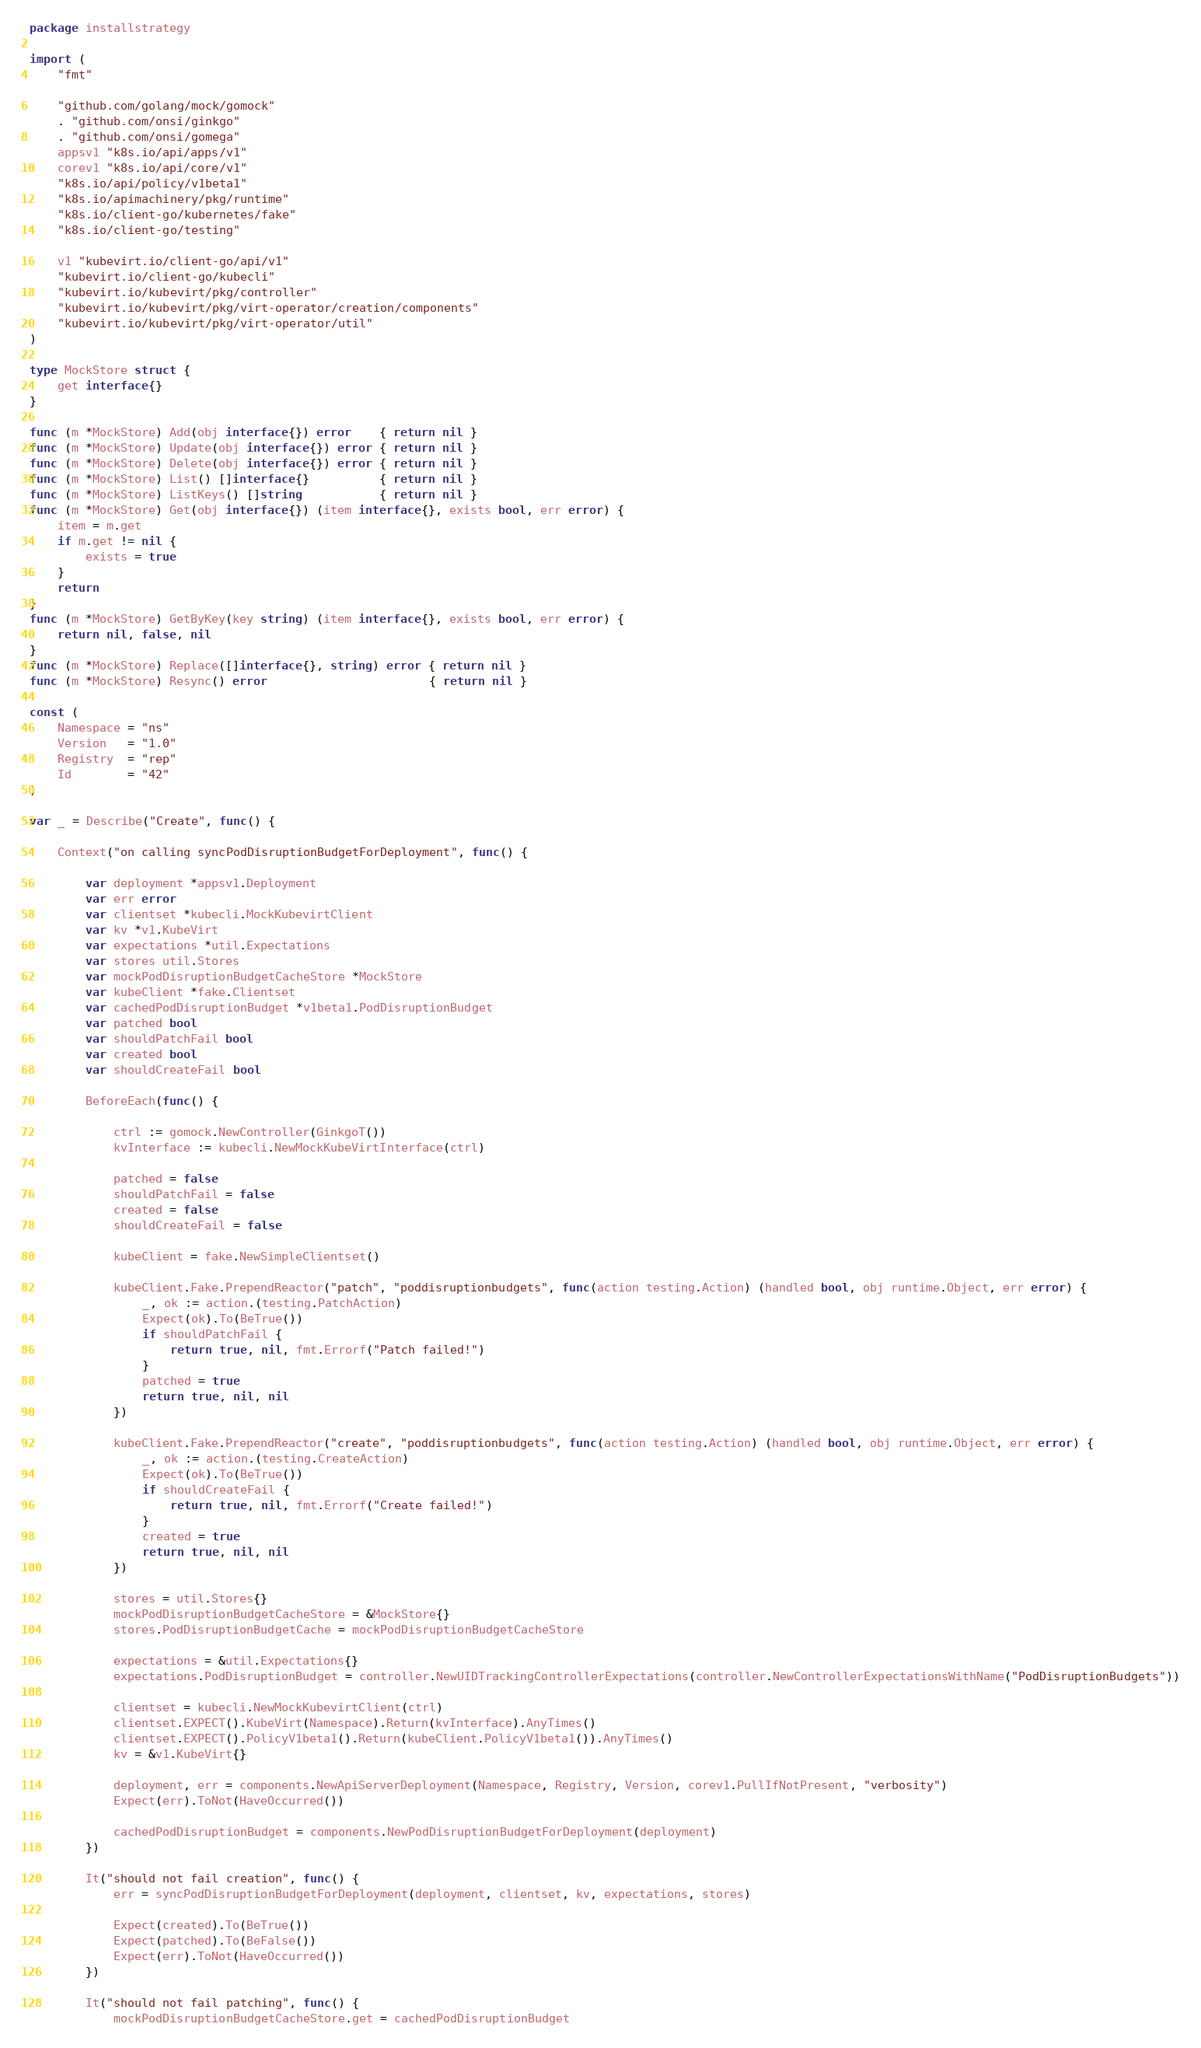Convert code to text. <code><loc_0><loc_0><loc_500><loc_500><_Go_>package installstrategy

import (
	"fmt"

	"github.com/golang/mock/gomock"
	. "github.com/onsi/ginkgo"
	. "github.com/onsi/gomega"
	appsv1 "k8s.io/api/apps/v1"
	corev1 "k8s.io/api/core/v1"
	"k8s.io/api/policy/v1beta1"
	"k8s.io/apimachinery/pkg/runtime"
	"k8s.io/client-go/kubernetes/fake"
	"k8s.io/client-go/testing"

	v1 "kubevirt.io/client-go/api/v1"
	"kubevirt.io/client-go/kubecli"
	"kubevirt.io/kubevirt/pkg/controller"
	"kubevirt.io/kubevirt/pkg/virt-operator/creation/components"
	"kubevirt.io/kubevirt/pkg/virt-operator/util"
)

type MockStore struct {
	get interface{}
}

func (m *MockStore) Add(obj interface{}) error    { return nil }
func (m *MockStore) Update(obj interface{}) error { return nil }
func (m *MockStore) Delete(obj interface{}) error { return nil }
func (m *MockStore) List() []interface{}          { return nil }
func (m *MockStore) ListKeys() []string           { return nil }
func (m *MockStore) Get(obj interface{}) (item interface{}, exists bool, err error) {
	item = m.get
	if m.get != nil {
		exists = true
	}
	return
}
func (m *MockStore) GetByKey(key string) (item interface{}, exists bool, err error) {
	return nil, false, nil
}
func (m *MockStore) Replace([]interface{}, string) error { return nil }
func (m *MockStore) Resync() error                       { return nil }

const (
	Namespace = "ns"
	Version   = "1.0"
	Registry  = "rep"
	Id        = "42"
)

var _ = Describe("Create", func() {

	Context("on calling syncPodDisruptionBudgetForDeployment", func() {

		var deployment *appsv1.Deployment
		var err error
		var clientset *kubecli.MockKubevirtClient
		var kv *v1.KubeVirt
		var expectations *util.Expectations
		var stores util.Stores
		var mockPodDisruptionBudgetCacheStore *MockStore
		var kubeClient *fake.Clientset
		var cachedPodDisruptionBudget *v1beta1.PodDisruptionBudget
		var patched bool
		var shouldPatchFail bool
		var created bool
		var shouldCreateFail bool

		BeforeEach(func() {

			ctrl := gomock.NewController(GinkgoT())
			kvInterface := kubecli.NewMockKubeVirtInterface(ctrl)

			patched = false
			shouldPatchFail = false
			created = false
			shouldCreateFail = false

			kubeClient = fake.NewSimpleClientset()

			kubeClient.Fake.PrependReactor("patch", "poddisruptionbudgets", func(action testing.Action) (handled bool, obj runtime.Object, err error) {
				_, ok := action.(testing.PatchAction)
				Expect(ok).To(BeTrue())
				if shouldPatchFail {
					return true, nil, fmt.Errorf("Patch failed!")
				}
				patched = true
				return true, nil, nil
			})

			kubeClient.Fake.PrependReactor("create", "poddisruptionbudgets", func(action testing.Action) (handled bool, obj runtime.Object, err error) {
				_, ok := action.(testing.CreateAction)
				Expect(ok).To(BeTrue())
				if shouldCreateFail {
					return true, nil, fmt.Errorf("Create failed!")
				}
				created = true
				return true, nil, nil
			})

			stores = util.Stores{}
			mockPodDisruptionBudgetCacheStore = &MockStore{}
			stores.PodDisruptionBudgetCache = mockPodDisruptionBudgetCacheStore

			expectations = &util.Expectations{}
			expectations.PodDisruptionBudget = controller.NewUIDTrackingControllerExpectations(controller.NewControllerExpectationsWithName("PodDisruptionBudgets"))

			clientset = kubecli.NewMockKubevirtClient(ctrl)
			clientset.EXPECT().KubeVirt(Namespace).Return(kvInterface).AnyTimes()
			clientset.EXPECT().PolicyV1beta1().Return(kubeClient.PolicyV1beta1()).AnyTimes()
			kv = &v1.KubeVirt{}

			deployment, err = components.NewApiServerDeployment(Namespace, Registry, Version, corev1.PullIfNotPresent, "verbosity")
			Expect(err).ToNot(HaveOccurred())

			cachedPodDisruptionBudget = components.NewPodDisruptionBudgetForDeployment(deployment)
		})

		It("should not fail creation", func() {
			err = syncPodDisruptionBudgetForDeployment(deployment, clientset, kv, expectations, stores)

			Expect(created).To(BeTrue())
			Expect(patched).To(BeFalse())
			Expect(err).ToNot(HaveOccurred())
		})

		It("should not fail patching", func() {
			mockPodDisruptionBudgetCacheStore.get = cachedPodDisruptionBudget
</code> 